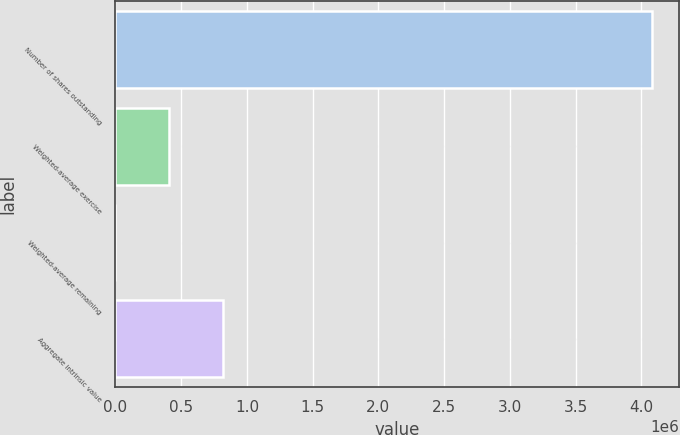Convert chart. <chart><loc_0><loc_0><loc_500><loc_500><bar_chart><fcel>Number of shares outstanding<fcel>Weighted-average exercise<fcel>Weighted-average remaining<fcel>Aggregate intrinsic value<nl><fcel>4.07991e+06<fcel>407996<fcel>5.85<fcel>815986<nl></chart> 